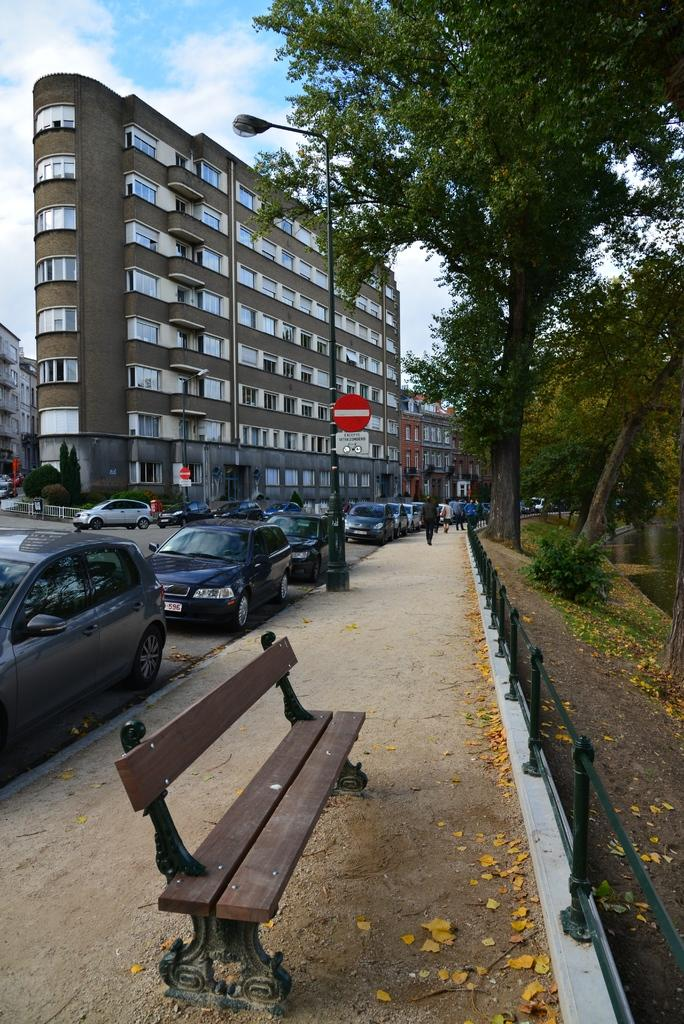What type of structure is present in the image? There is a building in the image. What type of vehicles can be seen in the image? There are cars on roads in the image. What type of vegetation is visible in the image? There are trees visible in the image. How many forks are visible in the image? There are no forks present in the image. What type of dirt can be seen on the cars in the image? There is no dirt visible on the cars in the image. 